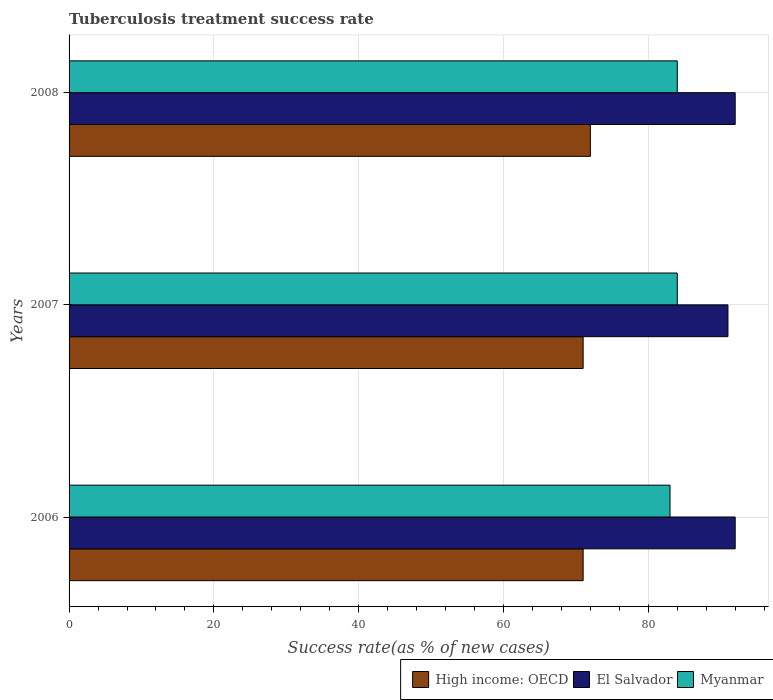How many different coloured bars are there?
Your response must be concise. 3. How many groups of bars are there?
Offer a very short reply. 3. Are the number of bars on each tick of the Y-axis equal?
Give a very brief answer. Yes. How many bars are there on the 1st tick from the bottom?
Ensure brevity in your answer.  3. In how many cases, is the number of bars for a given year not equal to the number of legend labels?
Provide a short and direct response. 0. What is the tuberculosis treatment success rate in El Salvador in 2006?
Give a very brief answer. 92. Across all years, what is the maximum tuberculosis treatment success rate in Myanmar?
Offer a terse response. 84. Across all years, what is the minimum tuberculosis treatment success rate in Myanmar?
Your answer should be very brief. 83. In which year was the tuberculosis treatment success rate in High income: OECD maximum?
Your answer should be very brief. 2008. What is the total tuberculosis treatment success rate in El Salvador in the graph?
Keep it short and to the point. 275. What is the difference between the tuberculosis treatment success rate in High income: OECD in 2007 and that in 2008?
Provide a short and direct response. -1. What is the average tuberculosis treatment success rate in El Salvador per year?
Your answer should be compact. 91.67. In how many years, is the tuberculosis treatment success rate in Myanmar greater than 32 %?
Give a very brief answer. 3. What is the ratio of the tuberculosis treatment success rate in High income: OECD in 2007 to that in 2008?
Ensure brevity in your answer.  0.99. Is the tuberculosis treatment success rate in Myanmar in 2007 less than that in 2008?
Offer a very short reply. No. What is the difference between the highest and the lowest tuberculosis treatment success rate in Myanmar?
Ensure brevity in your answer.  1. In how many years, is the tuberculosis treatment success rate in Myanmar greater than the average tuberculosis treatment success rate in Myanmar taken over all years?
Your response must be concise. 2. Is the sum of the tuberculosis treatment success rate in Myanmar in 2006 and 2007 greater than the maximum tuberculosis treatment success rate in El Salvador across all years?
Your answer should be very brief. Yes. What does the 1st bar from the top in 2006 represents?
Give a very brief answer. Myanmar. What does the 2nd bar from the bottom in 2008 represents?
Keep it short and to the point. El Salvador. How many bars are there?
Offer a terse response. 9. Does the graph contain grids?
Give a very brief answer. Yes. Where does the legend appear in the graph?
Ensure brevity in your answer.  Bottom right. How are the legend labels stacked?
Your response must be concise. Horizontal. What is the title of the graph?
Give a very brief answer. Tuberculosis treatment success rate. Does "Bermuda" appear as one of the legend labels in the graph?
Provide a succinct answer. No. What is the label or title of the X-axis?
Your answer should be very brief. Success rate(as % of new cases). What is the Success rate(as % of new cases) of High income: OECD in 2006?
Your answer should be very brief. 71. What is the Success rate(as % of new cases) of El Salvador in 2006?
Offer a terse response. 92. What is the Success rate(as % of new cases) of High income: OECD in 2007?
Offer a terse response. 71. What is the Success rate(as % of new cases) of El Salvador in 2007?
Make the answer very short. 91. What is the Success rate(as % of new cases) of Myanmar in 2007?
Provide a succinct answer. 84. What is the Success rate(as % of new cases) of High income: OECD in 2008?
Provide a short and direct response. 72. What is the Success rate(as % of new cases) of El Salvador in 2008?
Make the answer very short. 92. What is the Success rate(as % of new cases) of Myanmar in 2008?
Offer a terse response. 84. Across all years, what is the maximum Success rate(as % of new cases) of High income: OECD?
Your response must be concise. 72. Across all years, what is the maximum Success rate(as % of new cases) in El Salvador?
Give a very brief answer. 92. Across all years, what is the maximum Success rate(as % of new cases) in Myanmar?
Your answer should be very brief. 84. Across all years, what is the minimum Success rate(as % of new cases) in El Salvador?
Provide a succinct answer. 91. What is the total Success rate(as % of new cases) in High income: OECD in the graph?
Your answer should be compact. 214. What is the total Success rate(as % of new cases) of El Salvador in the graph?
Your answer should be very brief. 275. What is the total Success rate(as % of new cases) of Myanmar in the graph?
Your response must be concise. 251. What is the difference between the Success rate(as % of new cases) of El Salvador in 2006 and that in 2007?
Your answer should be very brief. 1. What is the difference between the Success rate(as % of new cases) of High income: OECD in 2006 and that in 2008?
Provide a short and direct response. -1. What is the difference between the Success rate(as % of new cases) of El Salvador in 2007 and that in 2008?
Your answer should be compact. -1. What is the difference between the Success rate(as % of new cases) in High income: OECD in 2006 and the Success rate(as % of new cases) in Myanmar in 2007?
Make the answer very short. -13. What is the difference between the Success rate(as % of new cases) in El Salvador in 2006 and the Success rate(as % of new cases) in Myanmar in 2008?
Ensure brevity in your answer.  8. What is the difference between the Success rate(as % of new cases) of High income: OECD in 2007 and the Success rate(as % of new cases) of El Salvador in 2008?
Your answer should be compact. -21. What is the difference between the Success rate(as % of new cases) in High income: OECD in 2007 and the Success rate(as % of new cases) in Myanmar in 2008?
Keep it short and to the point. -13. What is the difference between the Success rate(as % of new cases) in El Salvador in 2007 and the Success rate(as % of new cases) in Myanmar in 2008?
Ensure brevity in your answer.  7. What is the average Success rate(as % of new cases) of High income: OECD per year?
Make the answer very short. 71.33. What is the average Success rate(as % of new cases) of El Salvador per year?
Your answer should be very brief. 91.67. What is the average Success rate(as % of new cases) in Myanmar per year?
Provide a short and direct response. 83.67. In the year 2006, what is the difference between the Success rate(as % of new cases) in High income: OECD and Success rate(as % of new cases) in El Salvador?
Your answer should be compact. -21. In the year 2006, what is the difference between the Success rate(as % of new cases) in El Salvador and Success rate(as % of new cases) in Myanmar?
Your answer should be very brief. 9. In the year 2007, what is the difference between the Success rate(as % of new cases) of High income: OECD and Success rate(as % of new cases) of El Salvador?
Your answer should be very brief. -20. In the year 2007, what is the difference between the Success rate(as % of new cases) in High income: OECD and Success rate(as % of new cases) in Myanmar?
Your answer should be very brief. -13. In the year 2007, what is the difference between the Success rate(as % of new cases) in El Salvador and Success rate(as % of new cases) in Myanmar?
Offer a terse response. 7. What is the ratio of the Success rate(as % of new cases) in El Salvador in 2006 to that in 2007?
Provide a short and direct response. 1.01. What is the ratio of the Success rate(as % of new cases) in Myanmar in 2006 to that in 2007?
Offer a very short reply. 0.99. What is the ratio of the Success rate(as % of new cases) of High income: OECD in 2006 to that in 2008?
Give a very brief answer. 0.99. What is the ratio of the Success rate(as % of new cases) of El Salvador in 2006 to that in 2008?
Ensure brevity in your answer.  1. What is the ratio of the Success rate(as % of new cases) in High income: OECD in 2007 to that in 2008?
Your answer should be compact. 0.99. What is the difference between the highest and the second highest Success rate(as % of new cases) in El Salvador?
Offer a very short reply. 0. What is the difference between the highest and the second highest Success rate(as % of new cases) of Myanmar?
Your answer should be compact. 0. What is the difference between the highest and the lowest Success rate(as % of new cases) of High income: OECD?
Your answer should be compact. 1. What is the difference between the highest and the lowest Success rate(as % of new cases) in Myanmar?
Provide a succinct answer. 1. 